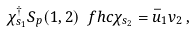Convert formula to latex. <formula><loc_0><loc_0><loc_500><loc_500>\chi ^ { \dagger } _ { s _ { 1 } } S _ { p } ( 1 , 2 ) \ f h c { \chi } _ { s _ { 2 } } = { \bar { u } } _ { 1 } v _ { 2 } \, ,</formula> 